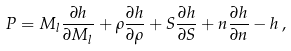Convert formula to latex. <formula><loc_0><loc_0><loc_500><loc_500>P = M _ { l } \frac { \partial h } { \partial M _ { l } } + \rho \frac { \partial h } { \partial \rho } + S \frac { \partial h } { \partial S } + n \frac { \partial h } { \partial n } - h \, ,</formula> 